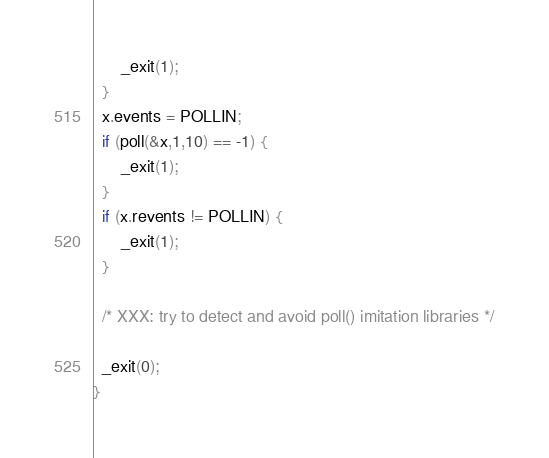<code> <loc_0><loc_0><loc_500><loc_500><_C_>      _exit(1);
  }
  x.events = POLLIN;
  if (poll(&x,1,10) == -1) {
      _exit(1);
  }
  if (x.revents != POLLIN) {
      _exit(1);
  }

  /* XXX: try to detect and avoid poll() imitation libraries */

  _exit(0);
}
</code> 